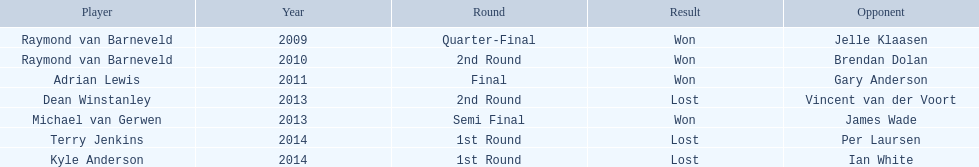Who are the competitors in the pdc world darts championship? Raymond van Barneveld, Raymond van Barneveld, Adrian Lewis, Dean Winstanley, Michael van Gerwen, Terry Jenkins, Kyle Anderson. When did kyle anderson face a loss? 2014. Which other participants were defeated in 2014? Terry Jenkins. Parse the full table. {'header': ['Player', 'Year', 'Round', 'Result', 'Opponent'], 'rows': [['Raymond van Barneveld', '2009', 'Quarter-Final', 'Won', 'Jelle Klaasen'], ['Raymond van Barneveld', '2010', '2nd Round', 'Won', 'Brendan Dolan'], ['Adrian Lewis', '2011', 'Final', 'Won', 'Gary Anderson'], ['Dean Winstanley', '2013', '2nd Round', 'Lost', 'Vincent van der Voort'], ['Michael van Gerwen', '2013', 'Semi Final', 'Won', 'James Wade'], ['Terry Jenkins', '2014', '1st Round', 'Lost', 'Per Laursen'], ['Kyle Anderson', '2014', '1st Round', 'Lost', 'Ian White']]} 